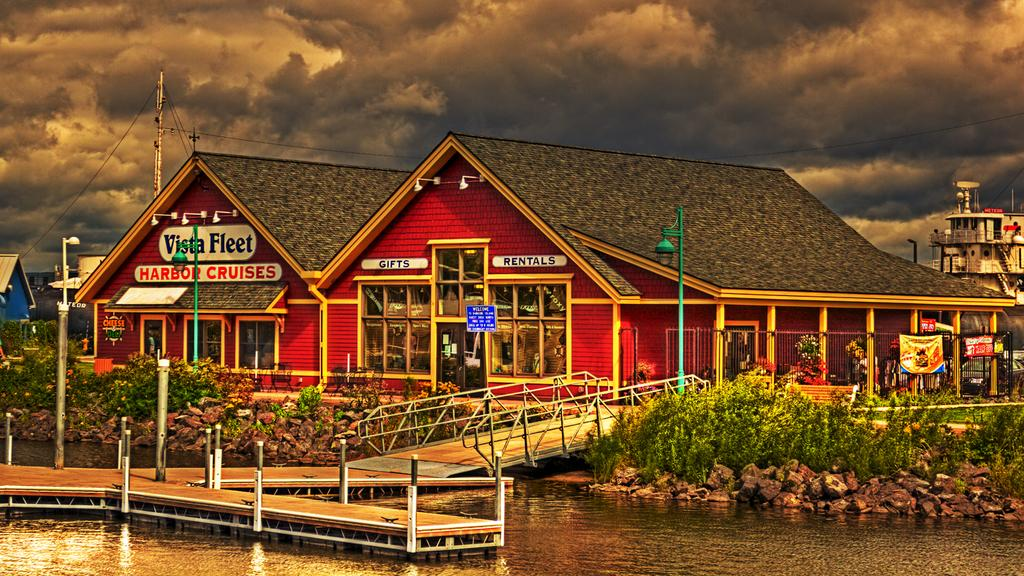What type of structures can be seen in the image? There are buildings in the image. What natural elements are present in the image? There are trees, plants, rocks, and water visible in the image. What man-made objects can be seen in the image? There are poles with wires and railings in the image. What is visible in the sky at the top of the image? There are clouds in the sky at the top of the image. Can you tell me how many necks are visible in the image? There is no reference to a neck or any body parts in the image, so it is not possible to answer that question. 